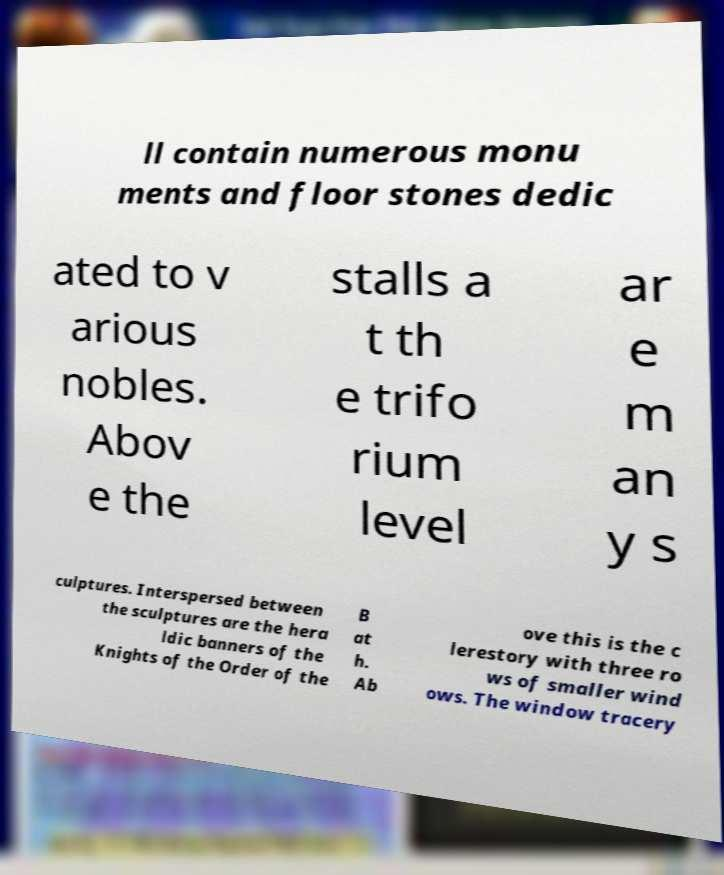Can you accurately transcribe the text from the provided image for me? ll contain numerous monu ments and floor stones dedic ated to v arious nobles. Abov e the stalls a t th e trifo rium level ar e m an y s culptures. Interspersed between the sculptures are the hera ldic banners of the Knights of the Order of the B at h. Ab ove this is the c lerestory with three ro ws of smaller wind ows. The window tracery 